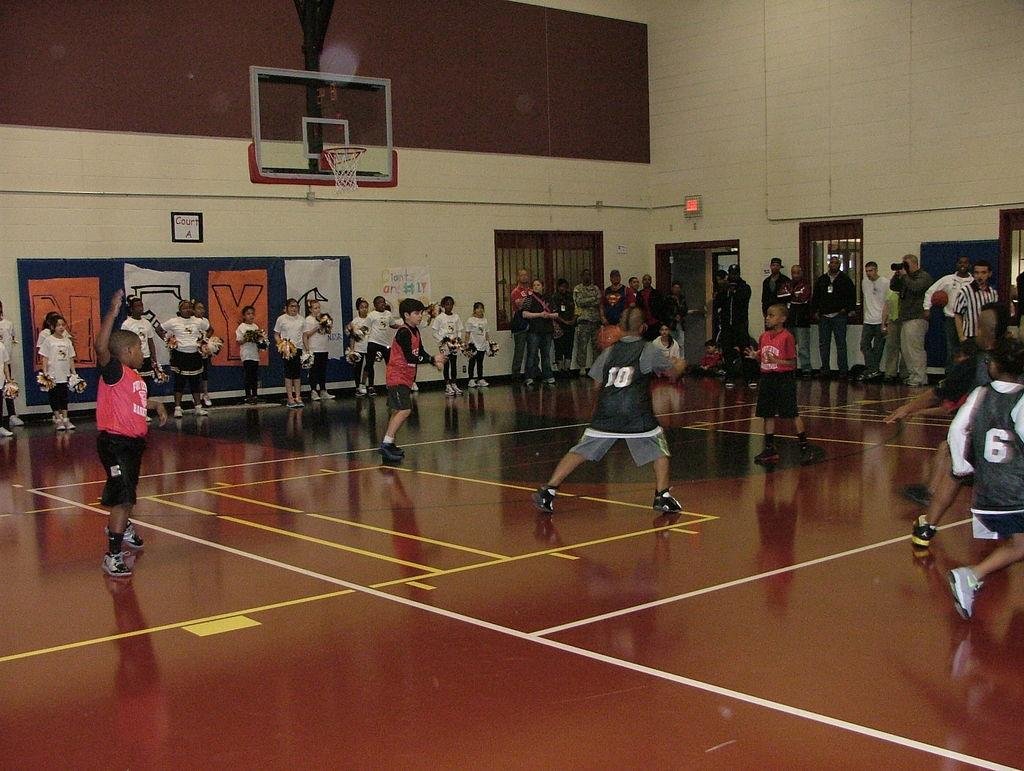<image>
Provide a brief description of the given image. Basketball players number ten and six on the court against three other players. 